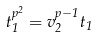<formula> <loc_0><loc_0><loc_500><loc_500>t _ { 1 } ^ { p ^ { 2 } } = v _ { 2 } ^ { p - 1 } t _ { 1 }</formula> 